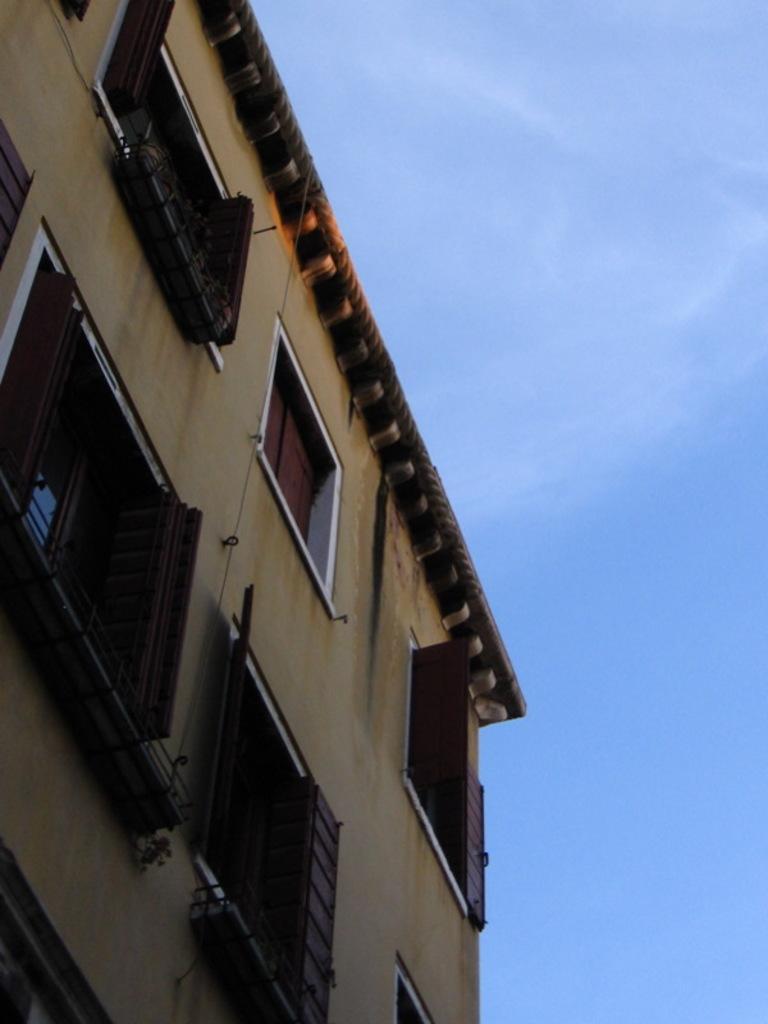In one or two sentences, can you explain what this image depicts? In this image we can see building. In the background there is sky. 